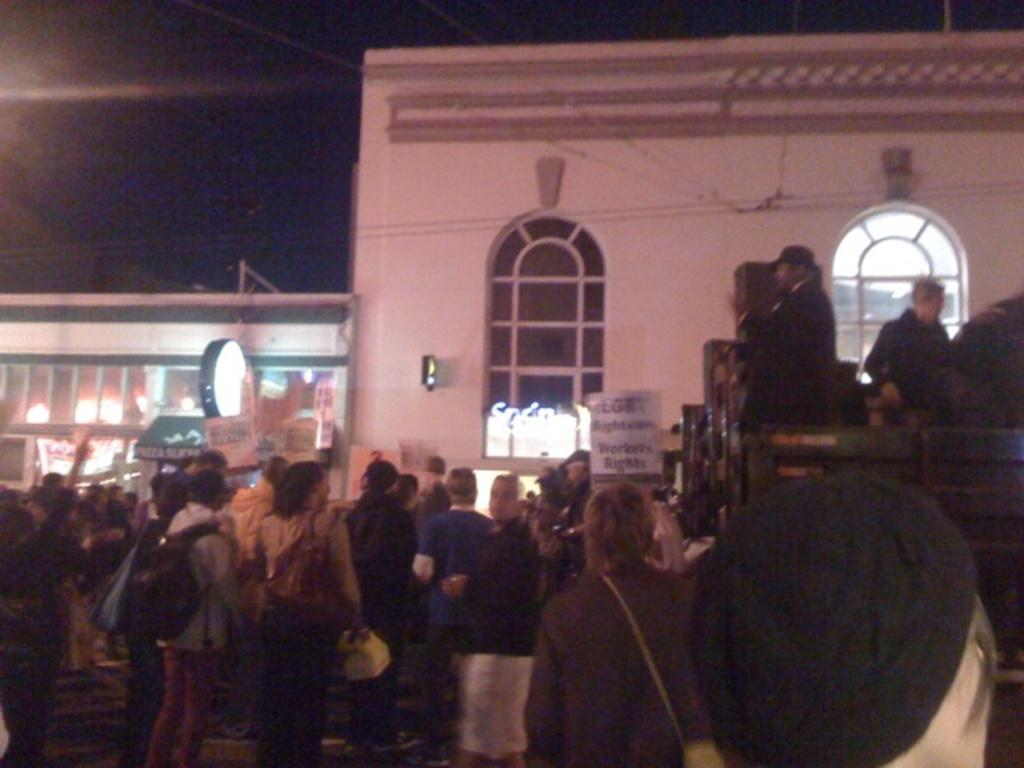What is happening in the image involving the group of people? The people in the image are standing and holding placards. What might the people be trying to communicate with their placards? The content of the placards is not visible in the image, so it cannot be determined what message they are conveying. What can be seen in the background of the image? There are houses and boards in the background of the image. How are the people positioned in the image? The people are standing, as mentioned in the facts. We can also infer that they are likely gathered together, given that they are holding placards. What type of prose is being recited by the people in the image? There is no indication in the image that the people are reciting any prose. How does the scale of the gate in the background relate to the size of the people in the image? There is no gate present in the image, so it is not possible to determine any relationship between its scale and the size of the people. 